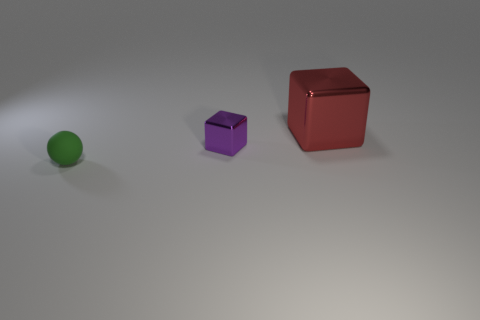Is there anything else that is the same material as the small green thing?
Your answer should be compact. No. What color is the metallic object that is left of the object to the right of the small object behind the small ball?
Ensure brevity in your answer.  Purple. Do the purple metallic cube and the sphere that is left of the red metal object have the same size?
Your answer should be compact. Yes. How many things are either cubes that are behind the small metal block or blocks in front of the red metal block?
Ensure brevity in your answer.  2. What shape is the purple shiny object that is the same size as the green matte object?
Ensure brevity in your answer.  Cube. What shape is the tiny thing right of the object that is in front of the small object behind the rubber ball?
Provide a succinct answer. Cube. Are there an equal number of small green things in front of the green ball and metallic things?
Your answer should be compact. No. Does the purple metal thing have the same size as the rubber thing?
Ensure brevity in your answer.  Yes. How many metal things are either balls or small yellow cylinders?
Offer a terse response. 0. What material is the purple cube that is the same size as the matte ball?
Your answer should be compact. Metal. 